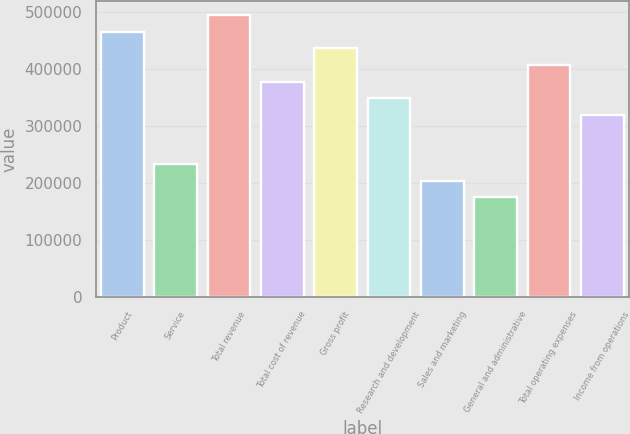Convert chart. <chart><loc_0><loc_0><loc_500><loc_500><bar_chart><fcel>Product<fcel>Service<fcel>Total revenue<fcel>Total cost of revenue<fcel>Gross profit<fcel>Research and development<fcel>Sales and marketing<fcel>General and administrative<fcel>Total operating expenses<fcel>Income from operations<nl><fcel>464417<fcel>232209<fcel>493443<fcel>377339<fcel>435391<fcel>348313<fcel>203183<fcel>174157<fcel>406365<fcel>319287<nl></chart> 